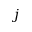Convert formula to latex. <formula><loc_0><loc_0><loc_500><loc_500>j</formula> 